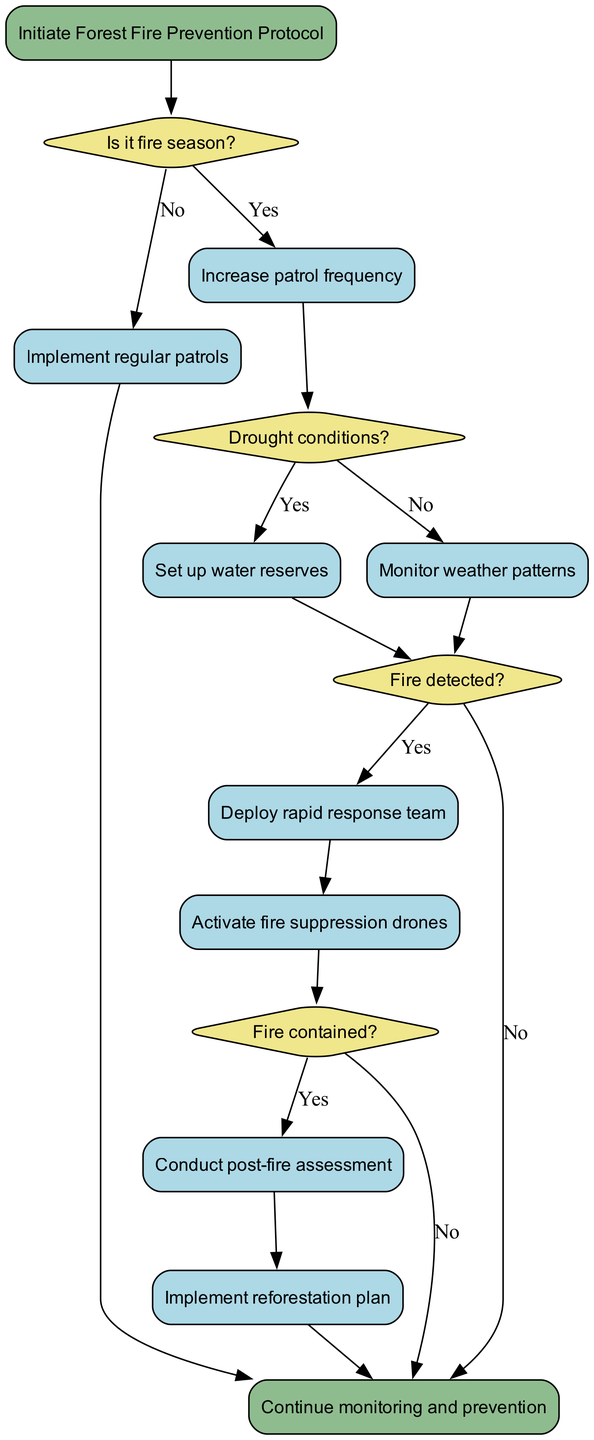What is the starting point of the diagram? The diagram begins with the node labeled "Initiate Forest Fire Prevention Protocol". This is indicated as the first node in the flowchart, showing the initiation of the process.
Answer: Initiate Forest Fire Prevention Protocol How many decision nodes are present in the diagram? There are four decision nodes in the diagram, as indicated by the diamond-shaped nodes that represent different points where decisions are made in the flow process.
Answer: 4 What action is taken if it is not fire season? If it is not fire season, the action taken is "Implement regular patrols". This is connected from the first decision node where "Is it fire season?" is answered as "No".
Answer: Implement regular patrols What happens when drought conditions are present? When drought conditions are present, the protocol involves "Set up water reserves". This is indicated by the flow from the second decision node when answered as "Yes".
Answer: Set up water reserves What follows after a fire is detected? After a fire is detected, the flow indicates that the "Deploy rapid response team" action will take place. This action is directly connected to the decision node that checks if a fire is detected.
Answer: Deploy rapid response team What actions are taken if the fire is contained? If the fire is contained, two actions are specified: "Conduct post-fire assessment" and "Implement reforestation plan". The first action leads to the second, suggesting a sequence of actions to be followed in response to the containment of the fire.
Answer: Conduct post-fire assessment, Implement reforestation plan What conditions must be fulfilled to activate fire suppression drones? Fire suppression drones are activated after a fire is detected, and they are deployed following the "Deploy rapid response team" action. This indicates that both the detection of fire and the deployment of the response team are prerequisite conditions to activate the drones.
Answer: Fire detected What is the terminal point of the flowchart? The end of the flowchart is labeled as "Continue monitoring and prevention". This indicates the conclusion of the protocol cycle, suggesting an ongoing process of vigilance post-response.
Answer: Continue monitoring and prevention 